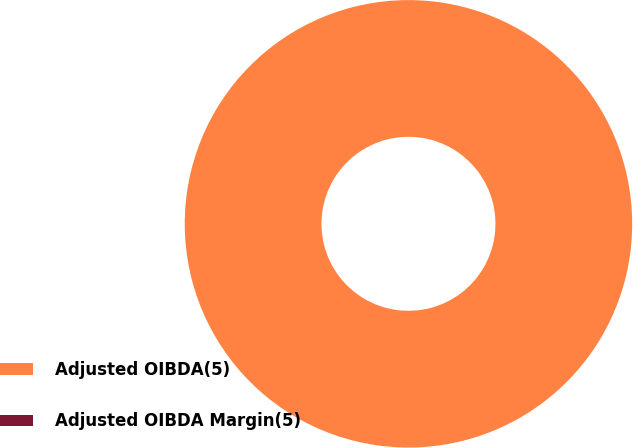<chart> <loc_0><loc_0><loc_500><loc_500><pie_chart><fcel>Adjusted OIBDA(5)<fcel>Adjusted OIBDA Margin(5)<nl><fcel>100.0%<fcel>0.0%<nl></chart> 